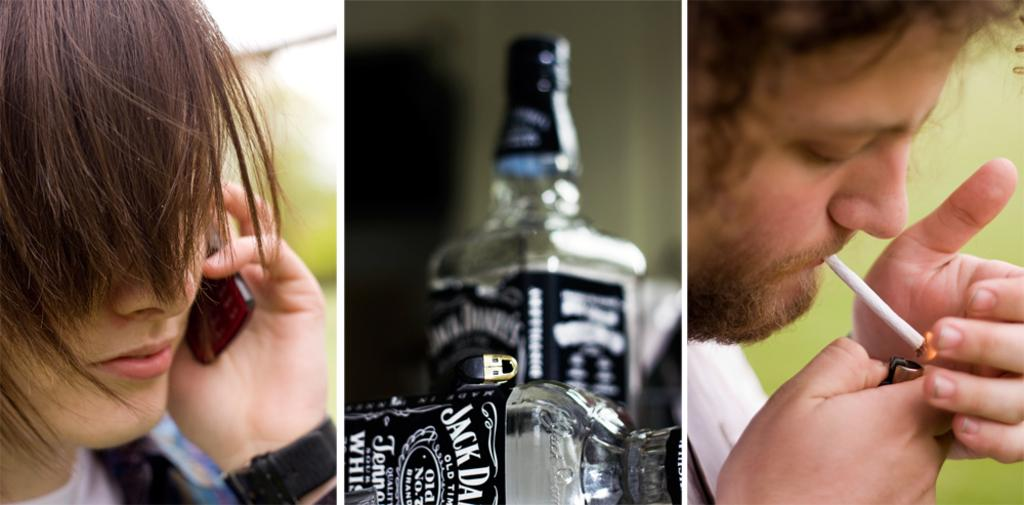<image>
Relay a brief, clear account of the picture shown. an image of someone on the phone, a bottle of jack daniels whiskey, and a man smoking 